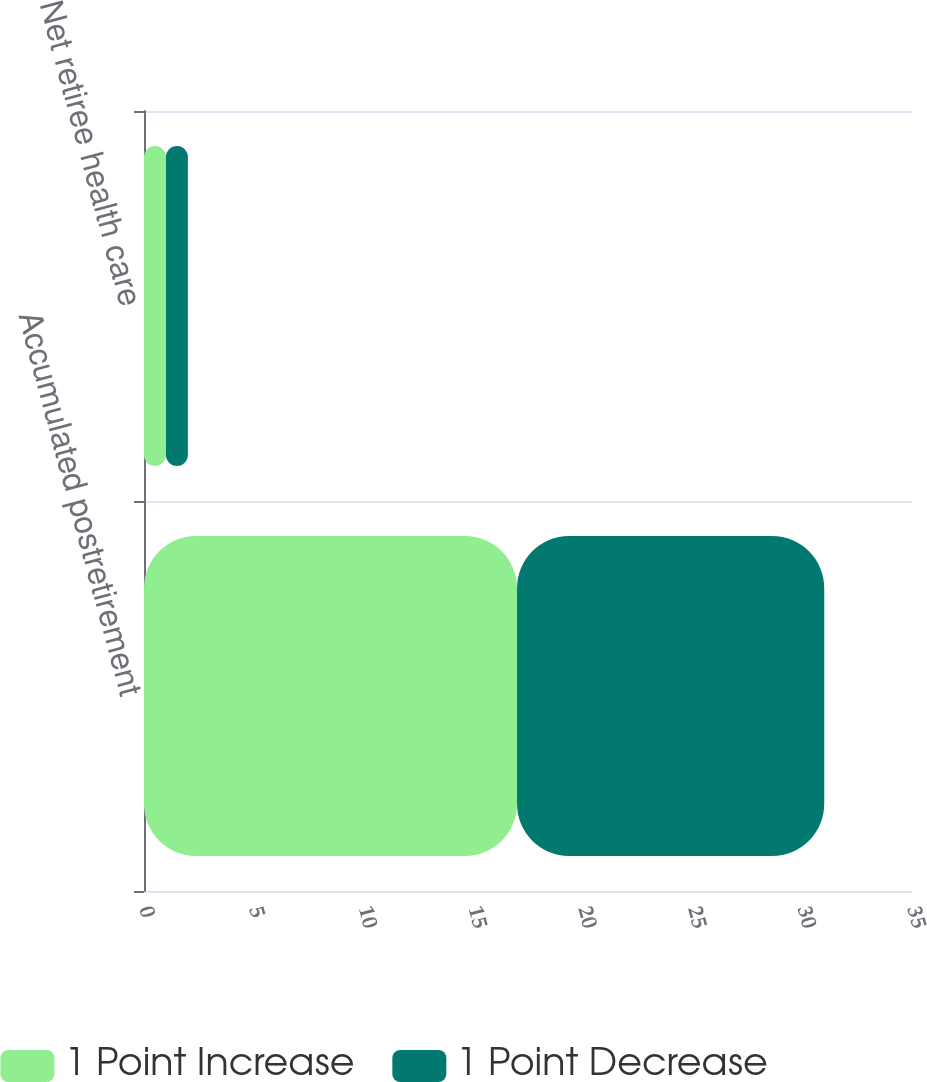<chart> <loc_0><loc_0><loc_500><loc_500><stacked_bar_chart><ecel><fcel>Accumulated postretirement<fcel>Net retiree health care<nl><fcel>1 Point Increase<fcel>17<fcel>1<nl><fcel>1 Point Decrease<fcel>14<fcel>1<nl></chart> 